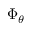<formula> <loc_0><loc_0><loc_500><loc_500>\Phi _ { \theta }</formula> 